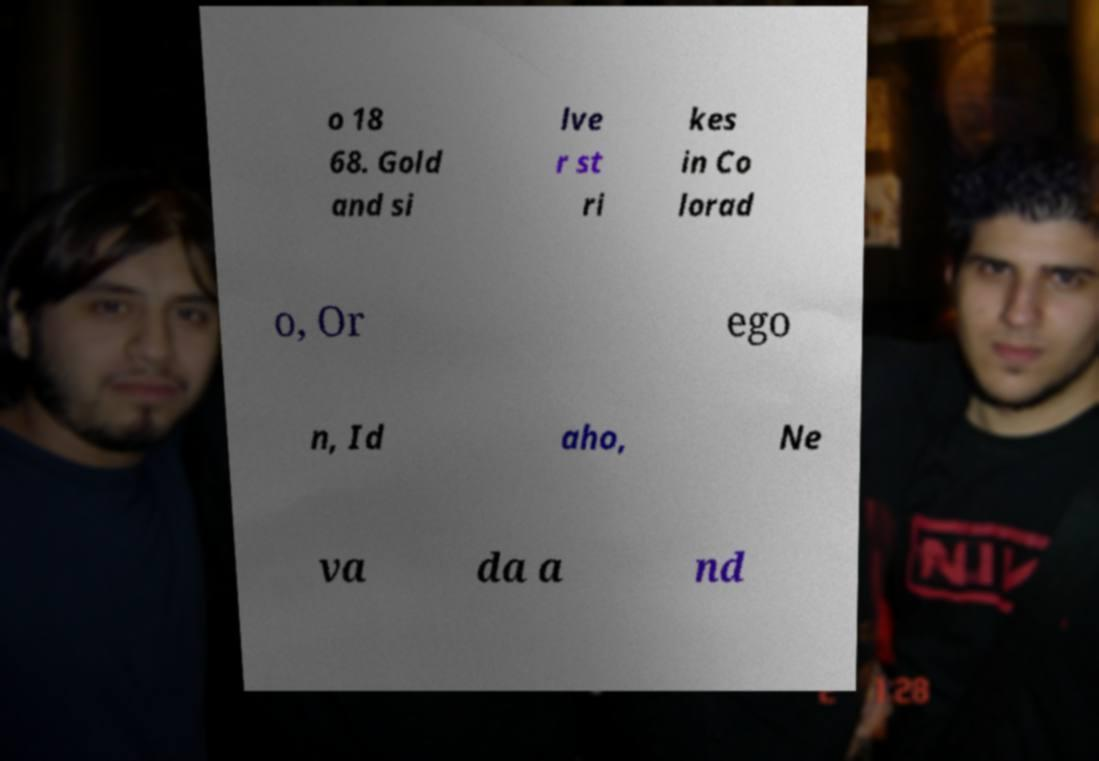I need the written content from this picture converted into text. Can you do that? o 18 68. Gold and si lve r st ri kes in Co lorad o, Or ego n, Id aho, Ne va da a nd 